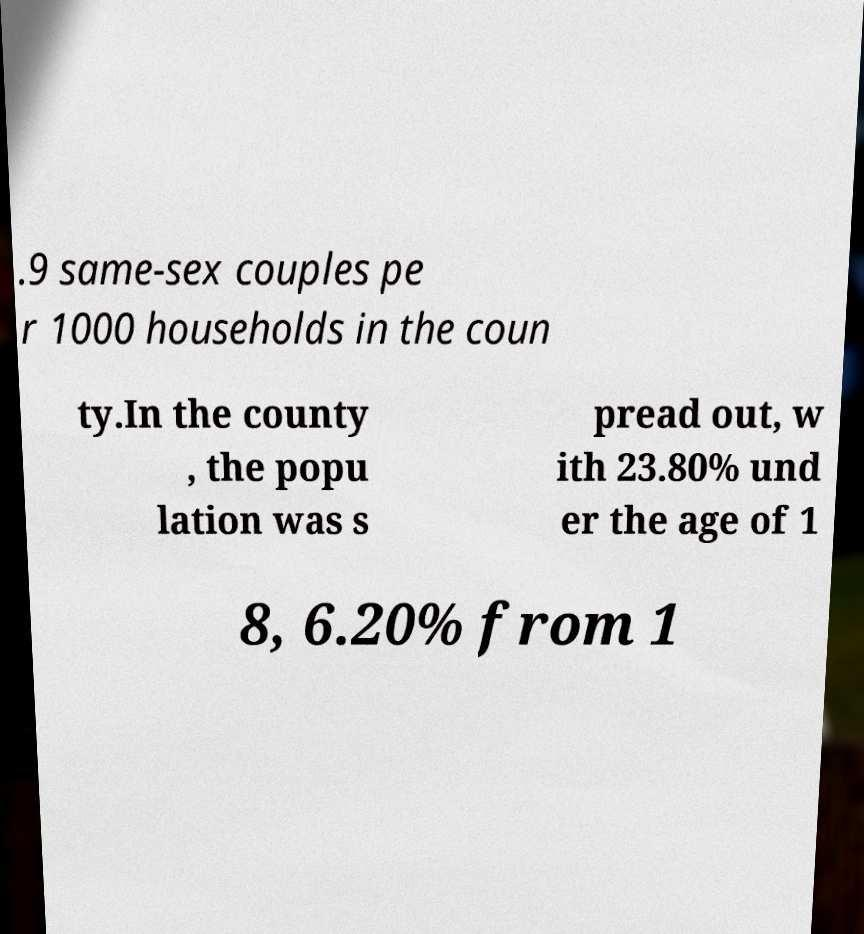What messages or text are displayed in this image? I need them in a readable, typed format. .9 same-sex couples pe r 1000 households in the coun ty.In the county , the popu lation was s pread out, w ith 23.80% und er the age of 1 8, 6.20% from 1 